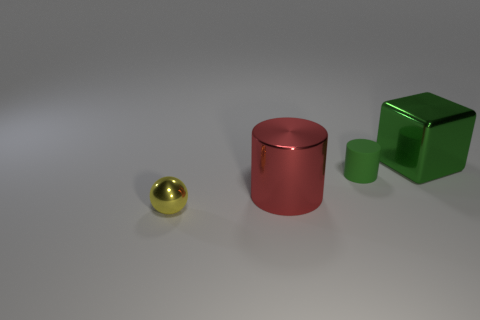Add 2 red metallic objects. How many objects exist? 6 Add 4 green rubber cubes. How many green rubber cubes exist? 4 Subtract 0 purple cylinders. How many objects are left? 4 Subtract all balls. How many objects are left? 3 Subtract all tiny purple matte blocks. Subtract all yellow balls. How many objects are left? 3 Add 2 yellow metallic objects. How many yellow metallic objects are left? 3 